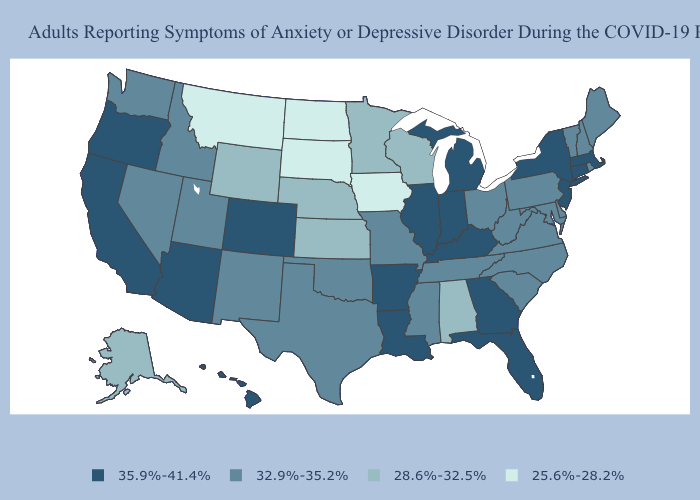Does Pennsylvania have the highest value in the Northeast?
Write a very short answer. No. Name the states that have a value in the range 28.6%-32.5%?
Quick response, please. Alabama, Alaska, Kansas, Minnesota, Nebraska, Wisconsin, Wyoming. Which states have the lowest value in the South?
Write a very short answer. Alabama. What is the lowest value in the USA?
Concise answer only. 25.6%-28.2%. Does the map have missing data?
Quick response, please. No. Name the states that have a value in the range 35.9%-41.4%?
Give a very brief answer. Arizona, Arkansas, California, Colorado, Connecticut, Florida, Georgia, Hawaii, Illinois, Indiana, Kentucky, Louisiana, Massachusetts, Michigan, New Jersey, New York, Oregon. Among the states that border Texas , does Oklahoma have the highest value?
Keep it brief. No. What is the value of Alabama?
Write a very short answer. 28.6%-32.5%. Among the states that border Michigan , which have the lowest value?
Short answer required. Wisconsin. Among the states that border Florida , does Alabama have the highest value?
Short answer required. No. Which states hav the highest value in the Northeast?
Concise answer only. Connecticut, Massachusetts, New Jersey, New York. What is the highest value in the Northeast ?
Concise answer only. 35.9%-41.4%. What is the value of Arkansas?
Answer briefly. 35.9%-41.4%. What is the value of New York?
Be succinct. 35.9%-41.4%. Does Illinois have the highest value in the MidWest?
Be succinct. Yes. 